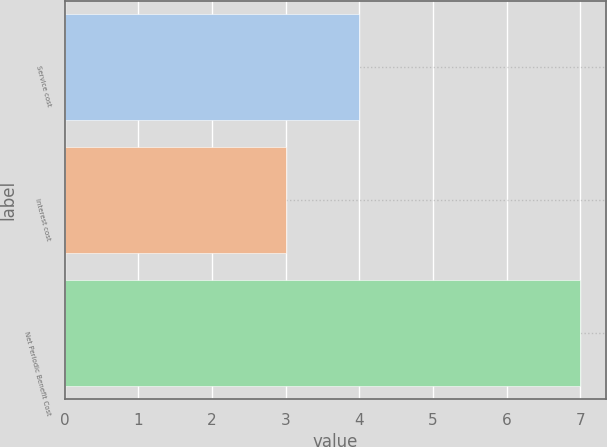Convert chart to OTSL. <chart><loc_0><loc_0><loc_500><loc_500><bar_chart><fcel>Service cost<fcel>Interest cost<fcel>Net Periodic Benefit Cost<nl><fcel>4<fcel>3<fcel>7<nl></chart> 